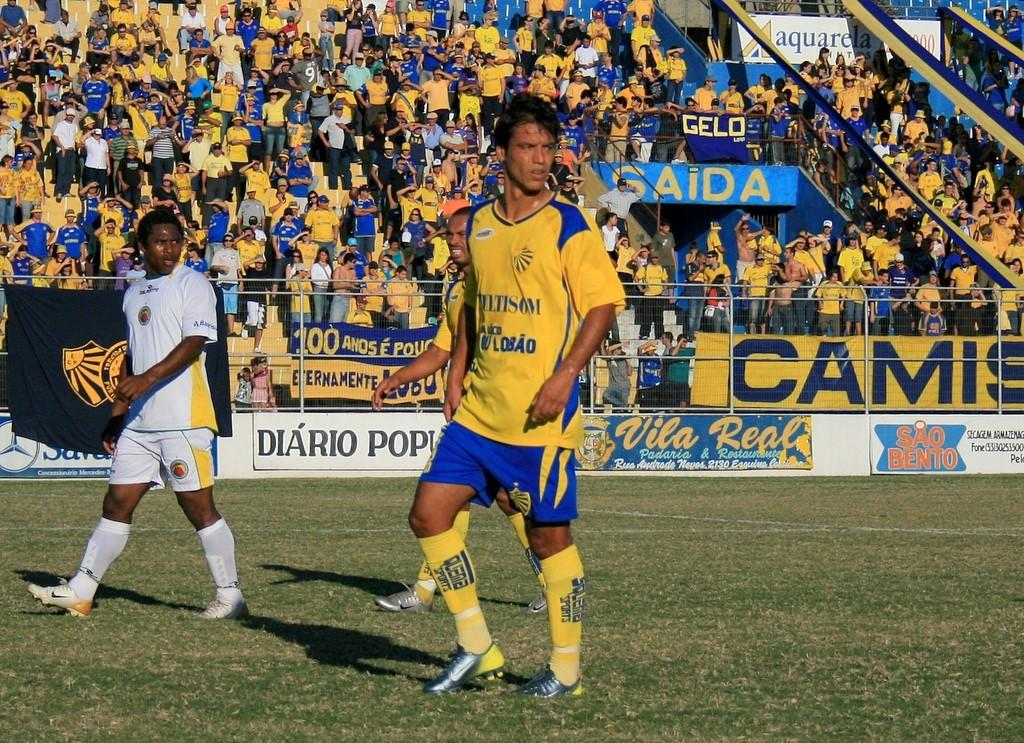<image>
Share a concise interpretation of the image provided. Sao Bento advertising on the wall at a soccer match 